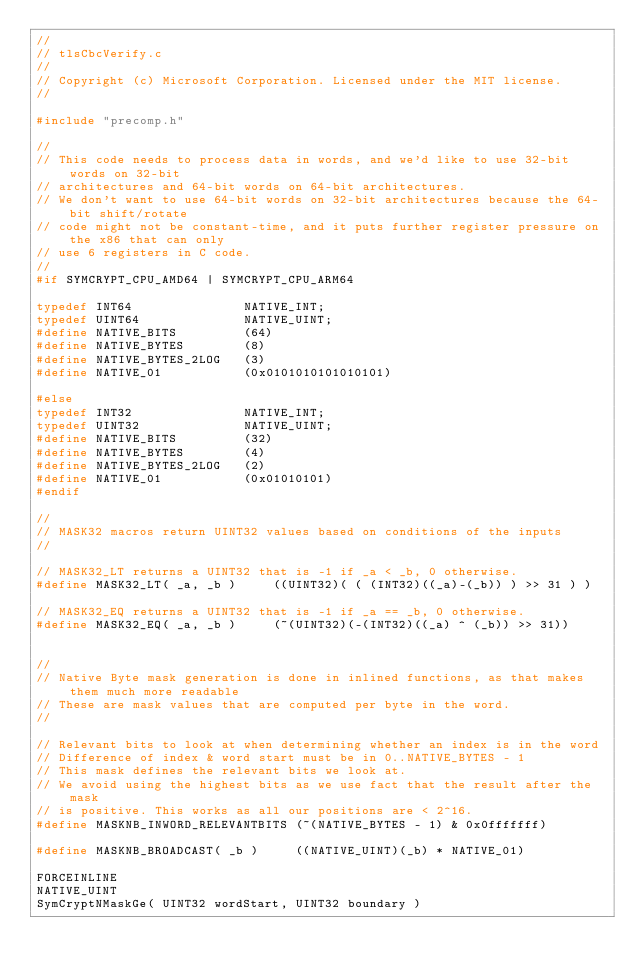<code> <loc_0><loc_0><loc_500><loc_500><_C_>//
// tlsCbcVerify.c
//
// Copyright (c) Microsoft Corporation. Licensed under the MIT license.
//

#include "precomp.h"

// 
// This code needs to process data in words, and we'd like to use 32-bit words on 32-bit 
// architectures and 64-bit words on 64-bit architectures.
// We don't want to use 64-bit words on 32-bit architectures because the 64-bit shift/rotate 
// code might not be constant-time, and it puts further register pressure on the x86 that can only
// use 6 registers in C code.
//
#if SYMCRYPT_CPU_AMD64 | SYMCRYPT_CPU_ARM64

typedef INT64               NATIVE_INT;
typedef UINT64              NATIVE_UINT;
#define NATIVE_BITS         (64)
#define NATIVE_BYTES        (8)
#define NATIVE_BYTES_2LOG   (3)
#define NATIVE_01           (0x0101010101010101)

#else 
typedef INT32               NATIVE_INT;
typedef UINT32              NATIVE_UINT;
#define NATIVE_BITS         (32)
#define NATIVE_BYTES        (4)
#define NATIVE_BYTES_2LOG   (2)
#define NATIVE_01           (0x01010101)
#endif

//
// MASK32 macros return UINT32 values based on conditions of the inputs
//

// MASK32_LT returns a UINT32 that is -1 if _a < _b, 0 otherwise.
#define MASK32_LT( _a, _b )     ((UINT32)( ( (INT32)((_a)-(_b)) ) >> 31 ) )

// MASK32_EQ returns a UINT32 that is -1 if _a == _b, 0 otherwise.
#define MASK32_EQ( _a, _b )     (~(UINT32)(-(INT32)((_a) ^ (_b)) >> 31))


//
// Native Byte mask generation is done in inlined functions, as that makes them much more readable
// These are mask values that are computed per byte in the word.
//

// Relevant bits to look at when determining whether an index is in the word
// Difference of index & word start must be in 0..NATIVE_BYTES - 1
// This mask defines the relevant bits we look at.
// We avoid using the highest bits as we use fact that the result after the mask
// is positive. This works as all our positions are < 2^16.
#define MASKNB_INWORD_RELEVANTBITS (~(NATIVE_BYTES - 1) & 0x0fffffff)

#define MASKNB_BROADCAST( _b )     ((NATIVE_UINT)(_b) * NATIVE_01)

FORCEINLINE
NATIVE_UINT
SymCryptNMaskGe( UINT32 wordStart, UINT32 boundary )</code> 